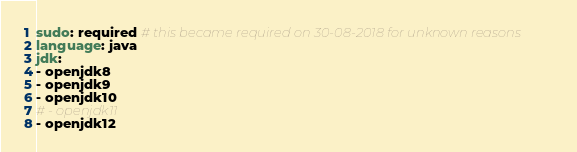Convert code to text. <code><loc_0><loc_0><loc_500><loc_500><_YAML_>sudo: required # this became required on 30-08-2018 for unknown reasons
language: java
jdk:
- openjdk8
- openjdk9
- openjdk10
# - openjdk11
- openjdk12
</code> 